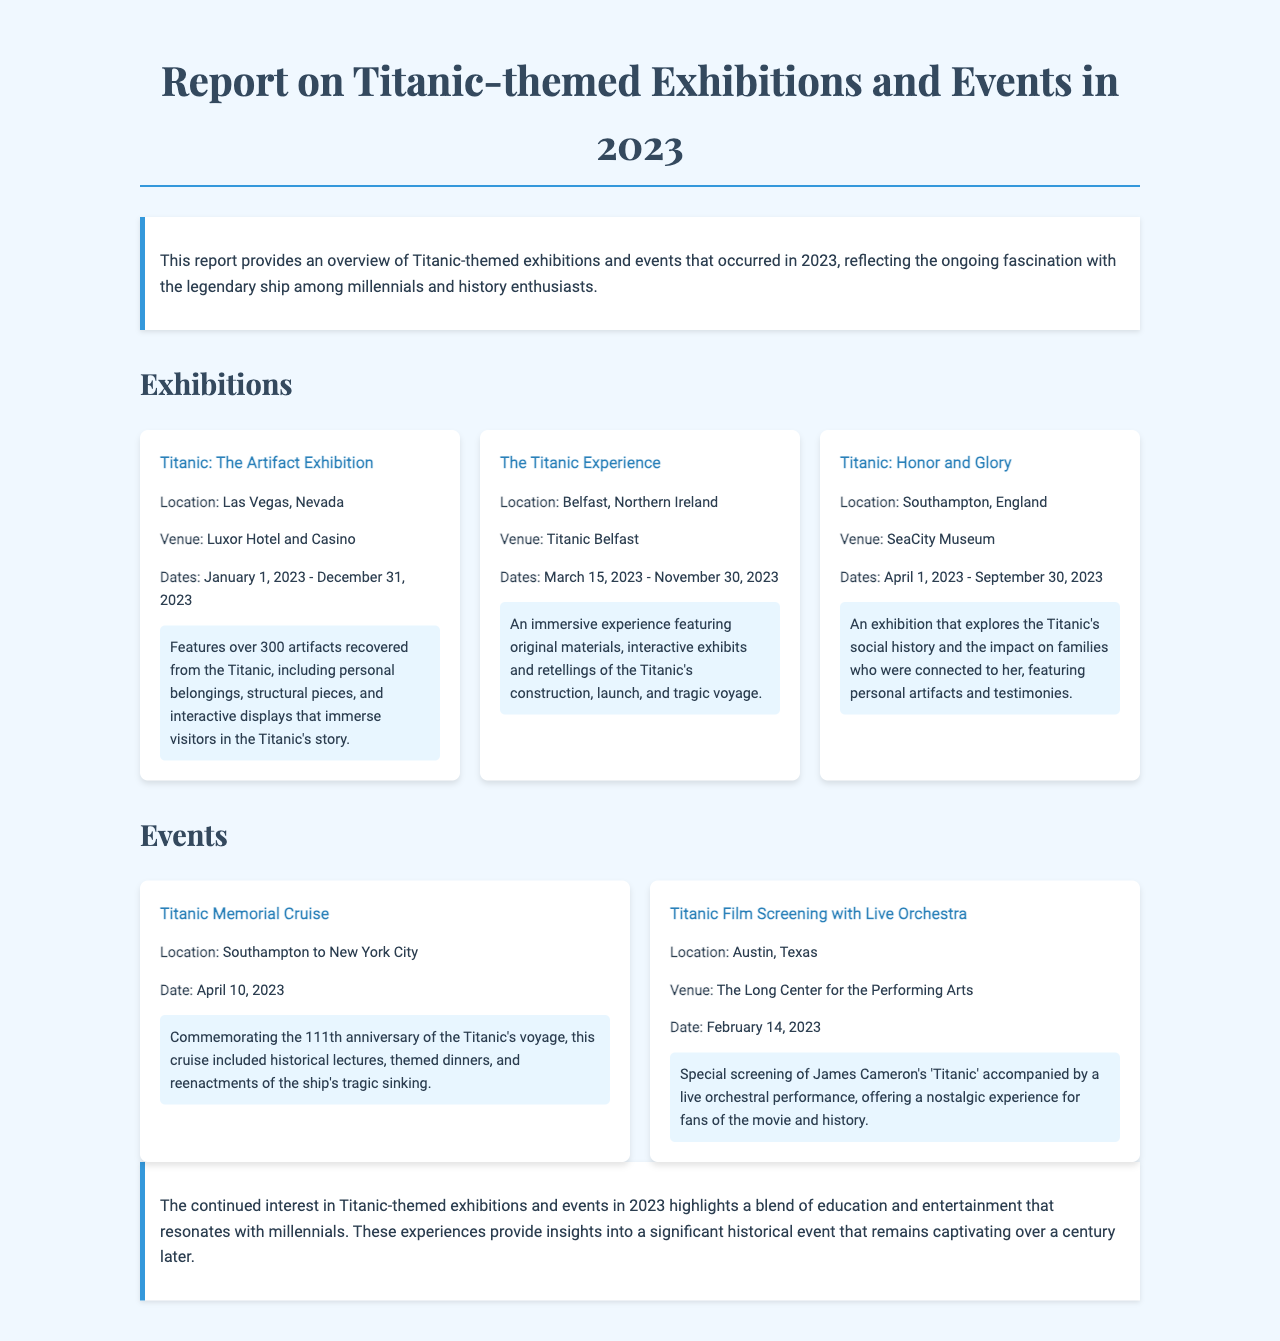What is the title of the report? The title of the report is presented prominently at the top of the document.
Answer: Report on Titanic-themed Exhibitions and Events in 2023 Where is the Titanic: The Artifact Exhibition located? This exhibition's location is explicitly mentioned in the section detailing the events and exhibitions.
Answer: Las Vegas, Nevada What are the dates of The Titanic Experience? The dates are provided in the timeline for the exhibition.
Answer: March 15, 2023 - November 30, 2023 Which exhibition features personal artifacts and testimonies? This refers to the specifics given about the exhibitions in the document.
Answer: Titanic: Honor and Glory How many artifacts are featured in Titanic: The Artifact Exhibition? The document states the number of artifacts in the exhibition.
Answer: Over 300 artifacts What major event is commemorated on April 10, 2023? This date is highlighted within the events section of the report.
Answer: Titanic Memorial Cruise Where did the Titanic Film Screening with Live Orchestra take place? The location of the film screening is mentioned in the event details.
Answer: Austin, Texas Which exhibition explores the Titanic's social history? This information is clearly outlined in the description of the exhibitions.
Answer: Titanic: Honor and Glory What kind of experience does The Titanic Experience offer? The details of the experience are summarized in the exhibition description.
Answer: Immersive experience 